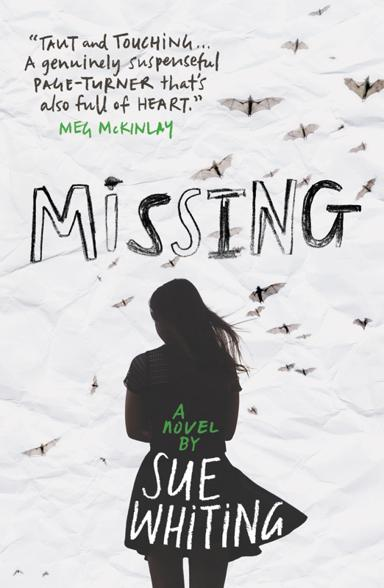Can you describe the overall design and atmosphere of the novel's cover? The cover of the novel 'Missing' by Sue Whiting features a stark and emotionally evocative design. The silhouette of a young person stands in the foreground, which may represent the protagonist or a central figure in the story. Above, the title 'MISSING' is written in what appears to be a distressed typeface, hinting at turmoil and mystery. The background is filled with butterfly images, symbolizing transformation or change, adding depth to the theme of loss and search central to the story. The overall atmosphere is one of suspense and emotion, setting the tone for the readers' journey ahead. 